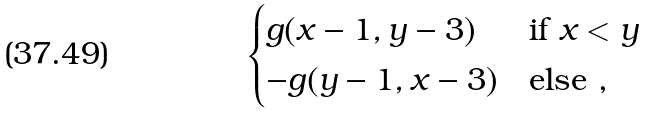<formula> <loc_0><loc_0><loc_500><loc_500>\begin{cases} g ( x - 1 , y - 3 ) & \text {if } x < y \\ - g ( y - 1 , x - 3 ) & \text {else ,} \end{cases}</formula> 